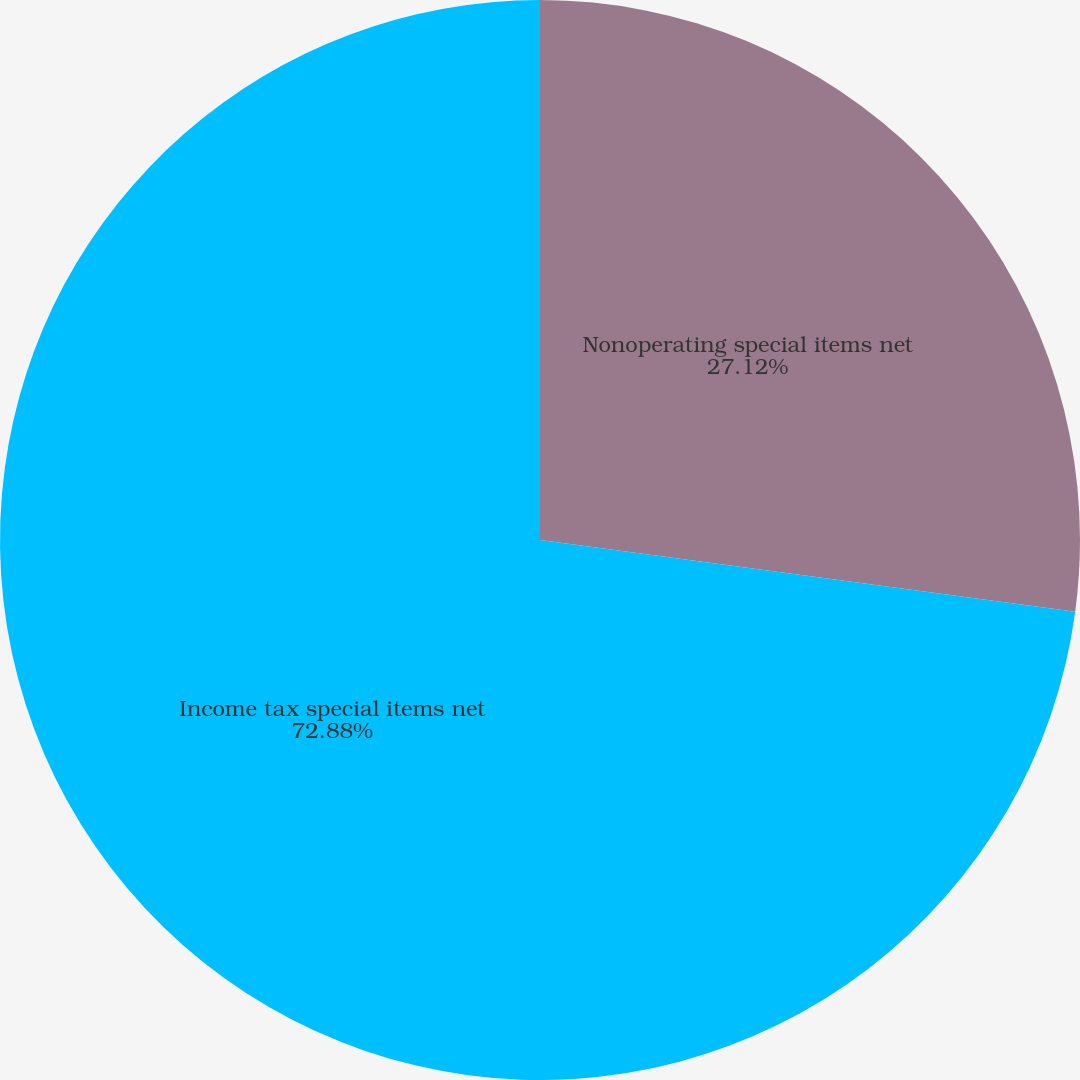Convert chart to OTSL. <chart><loc_0><loc_0><loc_500><loc_500><pie_chart><fcel>Nonoperating special items net<fcel>Income tax special items net<nl><fcel>27.12%<fcel>72.88%<nl></chart> 